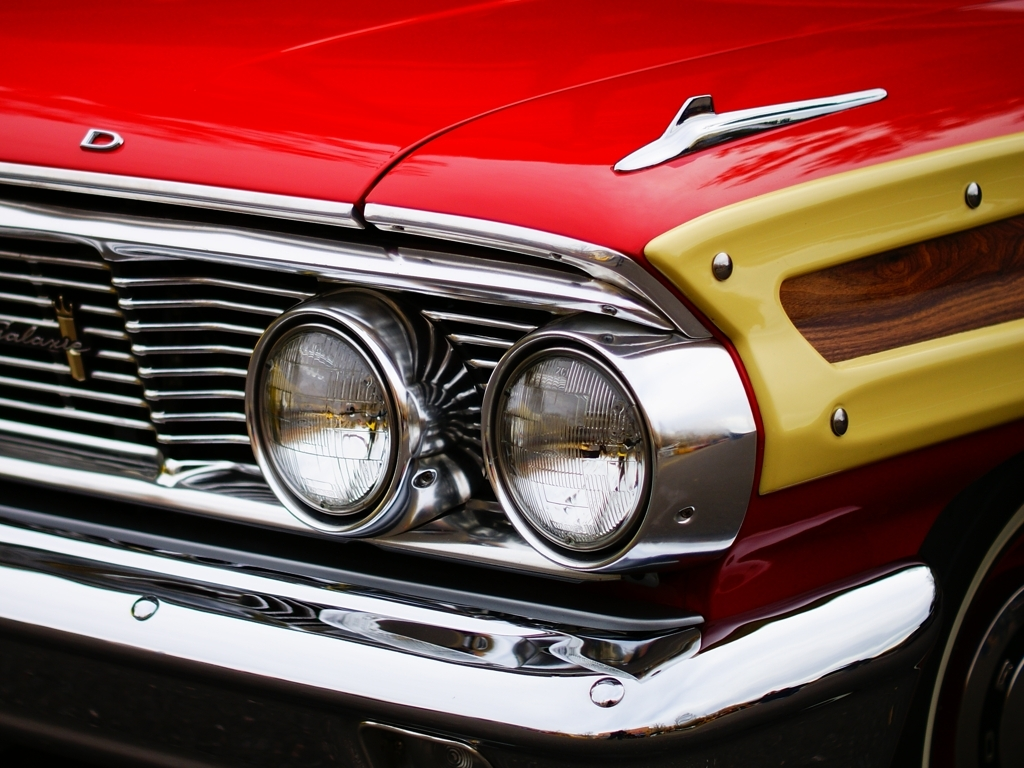How would you describe the details of the front end of the car? The front end of the car is designed with a distinctive retro aesthetic, showcasing chrome accents that gleam under the light and a bold two-tone color scheme. The headlights are encased in chrome bezels, sitting prominently on either side of a polished grille that features classic vertical slats. The attention to detail is meticulous, emphasizing the car's vintage charm and personality. 